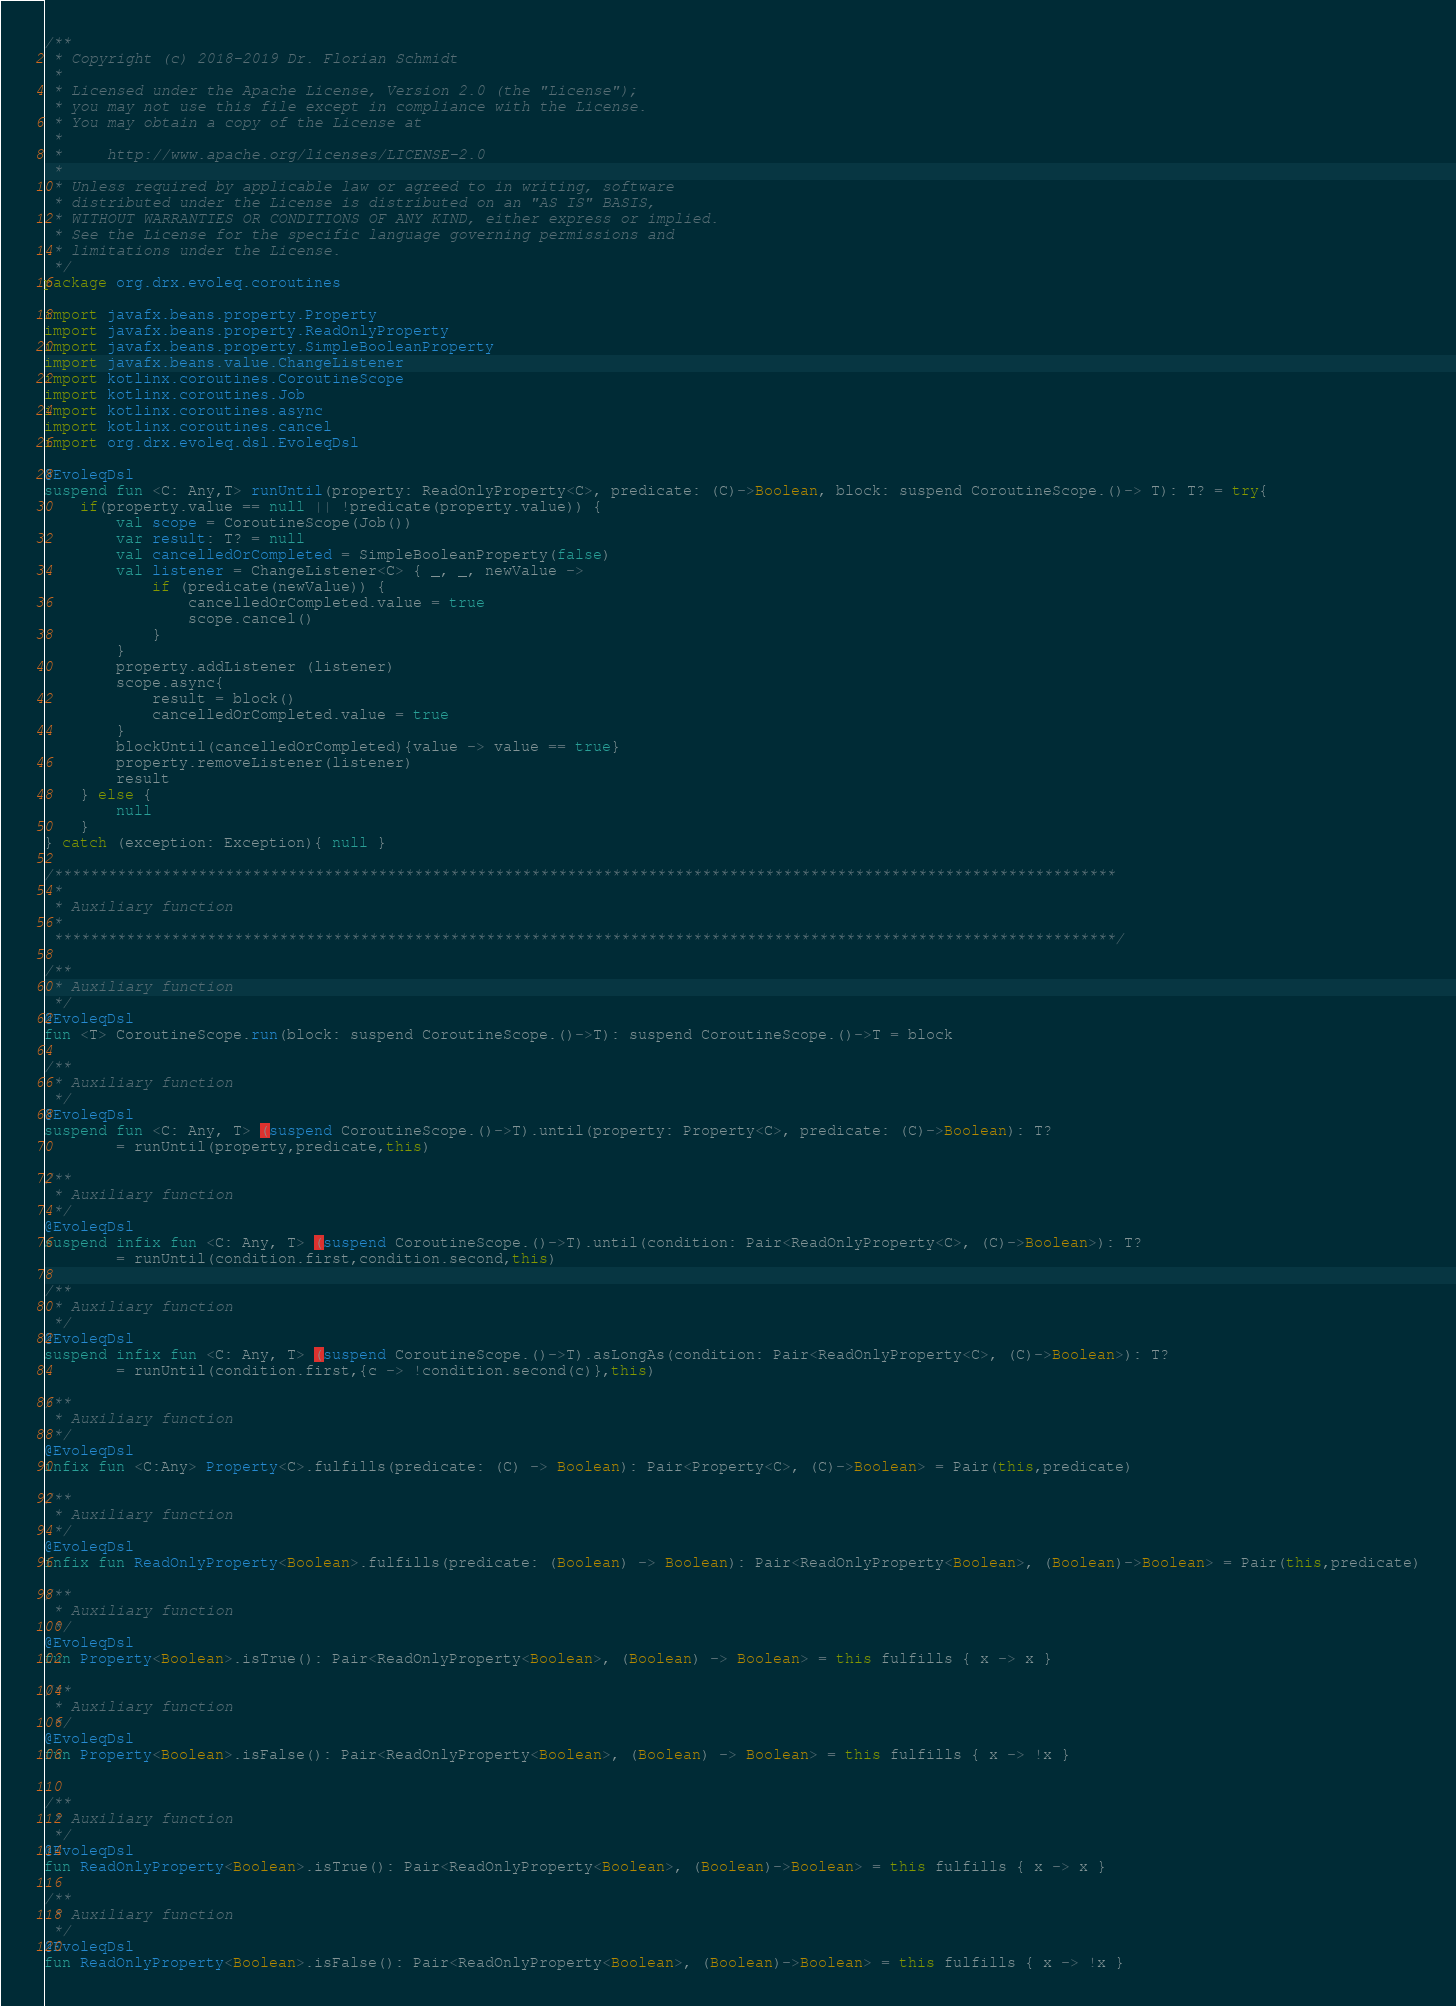Convert code to text. <code><loc_0><loc_0><loc_500><loc_500><_Kotlin_>/**
 * Copyright (c) 2018-2019 Dr. Florian Schmidt
 *
 * Licensed under the Apache License, Version 2.0 (the "License");
 * you may not use this file except in compliance with the License.
 * You may obtain a copy of the License at
 *
 *     http://www.apache.org/licenses/LICENSE-2.0
 *
 * Unless required by applicable law or agreed to in writing, software
 * distributed under the License is distributed on an "AS IS" BASIS,
 * WITHOUT WARRANTIES OR CONDITIONS OF ANY KIND, either express or implied.
 * See the License for the specific language governing permissions and
 * limitations under the License.
 */
package org.drx.evoleq.coroutines

import javafx.beans.property.Property
import javafx.beans.property.ReadOnlyProperty
import javafx.beans.property.SimpleBooleanProperty
import javafx.beans.value.ChangeListener
import kotlinx.coroutines.CoroutineScope
import kotlinx.coroutines.Job
import kotlinx.coroutines.async
import kotlinx.coroutines.cancel
import org.drx.evoleq.dsl.EvoleqDsl

@EvoleqDsl
suspend fun <C: Any,T> runUntil(property: ReadOnlyProperty<C>, predicate: (C)->Boolean, block: suspend CoroutineScope.()-> T): T? = try{
    if(property.value == null || !predicate(property.value)) {
        val scope = CoroutineScope(Job())
        var result: T? = null
        val cancelledOrCompleted = SimpleBooleanProperty(false)
        val listener = ChangeListener<C> { _, _, newValue ->
            if (predicate(newValue)) {
                cancelledOrCompleted.value = true
                scope.cancel()
            }
        }
        property.addListener (listener)
        scope.async{
            result = block()
            cancelledOrCompleted.value = true
        }
        blockUntil(cancelledOrCompleted){value -> value == true}
        property.removeListener(listener)
        result
    } else {
        null
    }
} catch (exception: Exception){ null }

/**********************************************************************************************************************
 *
 * Auxiliary function
 *
 **********************************************************************************************************************/

/**
 * Auxiliary function
 */
@EvoleqDsl
fun <T> CoroutineScope.run(block: suspend CoroutineScope.()->T): suspend CoroutineScope.()->T = block

/**
 * Auxiliary function
 */
@EvoleqDsl
suspend fun <C: Any, T> (suspend CoroutineScope.()->T).until(property: Property<C>, predicate: (C)->Boolean): T?
        = runUntil(property,predicate,this)

/**
 * Auxiliary function
 */
@EvoleqDsl
suspend infix fun <C: Any, T> (suspend CoroutineScope.()->T).until(condition: Pair<ReadOnlyProperty<C>, (C)->Boolean>): T?
        = runUntil(condition.first,condition.second,this)

/**
 * Auxiliary function
 */
@EvoleqDsl
suspend infix fun <C: Any, T> (suspend CoroutineScope.()->T).asLongAs(condition: Pair<ReadOnlyProperty<C>, (C)->Boolean>): T?
        = runUntil(condition.first,{c -> !condition.second(c)},this)

/**
 * Auxiliary function
 */
@EvoleqDsl
infix fun <C:Any> Property<C>.fulfills(predicate: (C) -> Boolean): Pair<Property<C>, (C)->Boolean> = Pair(this,predicate)

/**
 * Auxiliary function
 */
@EvoleqDsl
infix fun ReadOnlyProperty<Boolean>.fulfills(predicate: (Boolean) -> Boolean): Pair<ReadOnlyProperty<Boolean>, (Boolean)->Boolean> = Pair(this,predicate)

/**
 * Auxiliary function
 */
@EvoleqDsl
fun Property<Boolean>.isTrue(): Pair<ReadOnlyProperty<Boolean>, (Boolean) -> Boolean> = this fulfills { x -> x }

/**
 * Auxiliary function
 */
@EvoleqDsl
fun Property<Boolean>.isFalse(): Pair<ReadOnlyProperty<Boolean>, (Boolean) -> Boolean> = this fulfills { x -> !x }


/**
 * Auxiliary function
 */
@EvoleqDsl
fun ReadOnlyProperty<Boolean>.isTrue(): Pair<ReadOnlyProperty<Boolean>, (Boolean)->Boolean> = this fulfills { x -> x }

/**
 * Auxiliary function
 */
@EvoleqDsl
fun ReadOnlyProperty<Boolean>.isFalse(): Pair<ReadOnlyProperty<Boolean>, (Boolean)->Boolean> = this fulfills { x -> !x }

</code> 